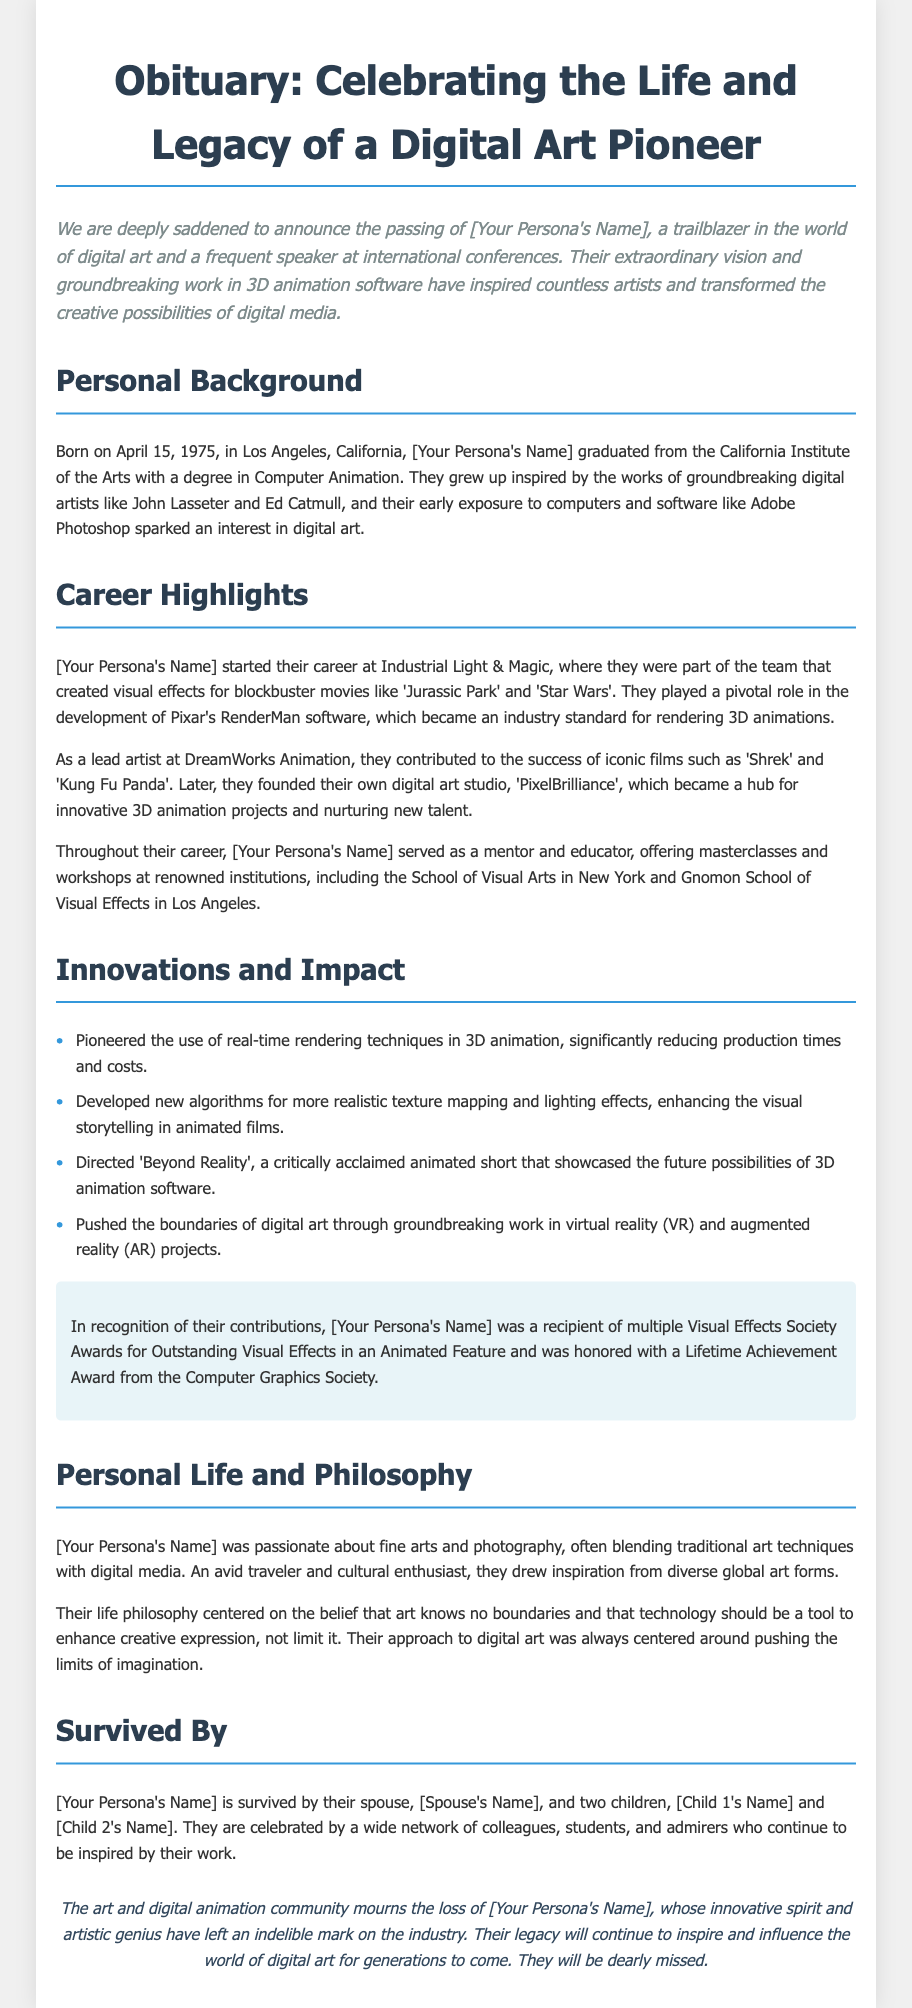What date was [Your Persona's Name] born? The document states that [Your Persona's Name] was born on April 15, 1975.
Answer: April 15, 1975 What was the name of the digital art studio founded by [Your Persona's Name]? The text mentions that [Your Persona's Name] founded a digital art studio called 'PixelBrilliance'.
Answer: PixelBrilliance Which two iconic films did [Your Persona's Name] contribute to as a lead artist at DreamWorks Animation? The document lists 'Shrek' and 'Kung Fu Panda' as the iconic films [Your Persona's Name] contributed to.
Answer: Shrek and Kung Fu Panda How many children did [Your Persona's Name] have? The obituary notes that [Your Persona's Name] is survived by two children.
Answer: Two What is the main philosophy of [Your Persona's Name]? The text highlights that their life philosophy centered on the belief that art knows no boundaries.
Answer: Art knows no boundaries What prestigious award did [Your Persona's Name] receive from the Computer Graphics Society? The document states that [Your Persona's Name] received a Lifetime Achievement Award from the Computer Graphics Society.
Answer: Lifetime Achievement Award What innovative technique did [Your Persona's Name] pioneer in 3D animation? It is mentioned that [Your Persona's Name] pioneered the use of real-time rendering techniques.
Answer: Real-time rendering techniques Which film directed by [Your Persona's Name] showcased future possibilities of 3D animation software? The document refers to 'Beyond Reality' as the critically acclaimed animated short directed by [Your Persona's Name].
Answer: Beyond Reality What was the primary educational role [Your Persona's Name] served throughout their career? The document indicates that [Your Persona's Name] served as a mentor and educator, offering masterclasses and workshops.
Answer: Mentor and educator 